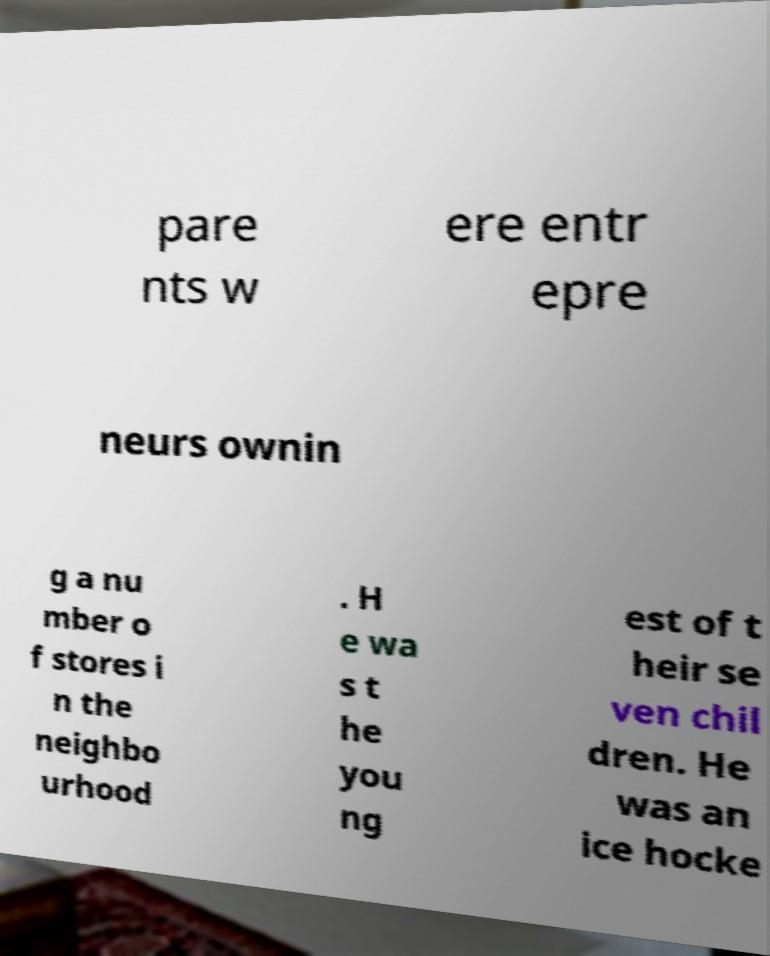Could you assist in decoding the text presented in this image and type it out clearly? pare nts w ere entr epre neurs ownin g a nu mber o f stores i n the neighbo urhood . H e wa s t he you ng est of t heir se ven chil dren. He was an ice hocke 